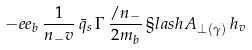<formula> <loc_0><loc_0><loc_500><loc_500>- e e _ { b } \, \frac { 1 } { n _ { - } v } \, \bar { q } _ { s } \, \Gamma \, \frac { \slash n _ { - } } { 2 m _ { b } } \, \S l a s h A _ { \perp ( \gamma ) } \, h _ { v }</formula> 